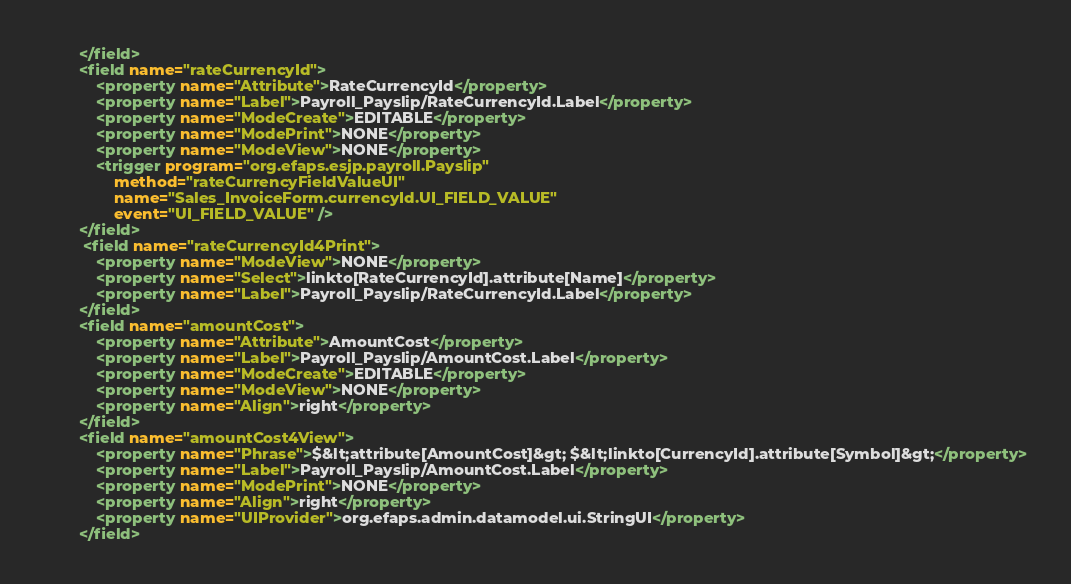<code> <loc_0><loc_0><loc_500><loc_500><_XML_>        </field>
        <field name="rateCurrencyId">
            <property name="Attribute">RateCurrencyId</property>
            <property name="Label">Payroll_Payslip/RateCurrencyId.Label</property>
            <property name="ModeCreate">EDITABLE</property>
            <property name="ModePrint">NONE</property>
            <property name="ModeView">NONE</property>
            <trigger program="org.efaps.esjp.payroll.Payslip"
                method="rateCurrencyFieldValueUI"
                name="Sales_InvoiceForm.currencyId.UI_FIELD_VALUE"
                event="UI_FIELD_VALUE" />
        </field>
         <field name="rateCurrencyId4Print">
            <property name="ModeView">NONE</property>
            <property name="Select">linkto[RateCurrencyId].attribute[Name]</property>
            <property name="Label">Payroll_Payslip/RateCurrencyId.Label</property>
        </field>
        <field name="amountCost">
            <property name="Attribute">AmountCost</property>
            <property name="Label">Payroll_Payslip/AmountCost.Label</property>
            <property name="ModeCreate">EDITABLE</property>
            <property name="ModeView">NONE</property>
            <property name="Align">right</property>
        </field>
        <field name="amountCost4View">
            <property name="Phrase">$&lt;attribute[AmountCost]&gt; $&lt;linkto[CurrencyId].attribute[Symbol]&gt;</property>
            <property name="Label">Payroll_Payslip/AmountCost.Label</property>
            <property name="ModePrint">NONE</property>
            <property name="Align">right</property>
            <property name="UIProvider">org.efaps.admin.datamodel.ui.StringUI</property>
        </field></code> 